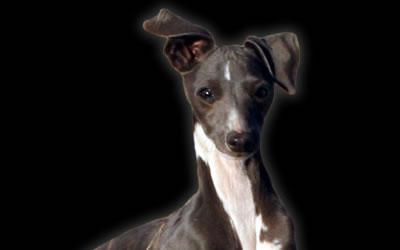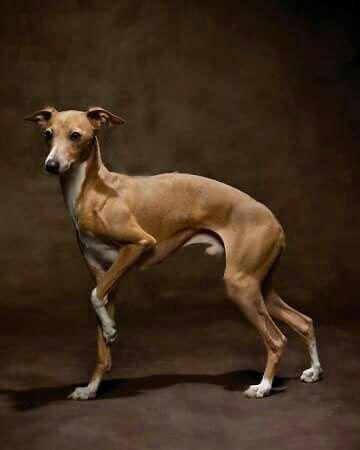The first image is the image on the left, the second image is the image on the right. Considering the images on both sides, is "The dog on the right image is facing left." valid? Answer yes or no. Yes. 